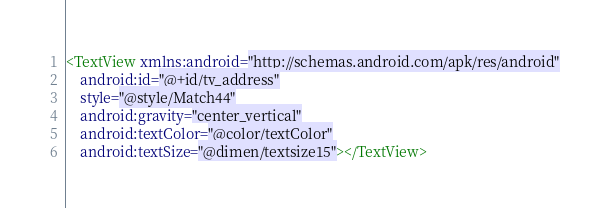<code> <loc_0><loc_0><loc_500><loc_500><_XML_><TextView xmlns:android="http://schemas.android.com/apk/res/android"
    android:id="@+id/tv_address"
    style="@style/Match44"
    android:gravity="center_vertical"
    android:textColor="@color/textColor"
    android:textSize="@dimen/textsize15"></TextView></code> 